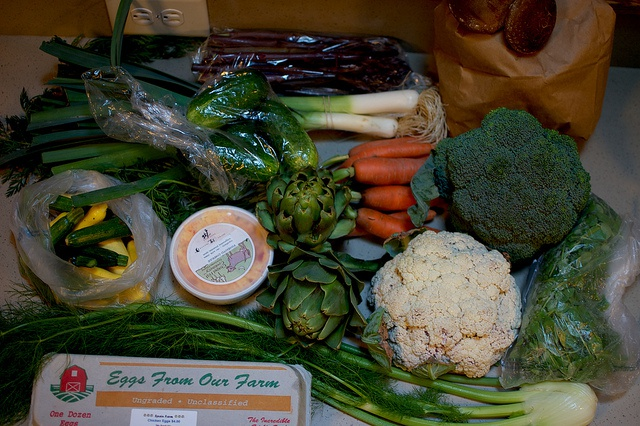Describe the objects in this image and their specific colors. I can see broccoli in maroon, black, darkgreen, teal, and gray tones, carrot in maroon, brown, and olive tones, carrot in maroon, brown, and black tones, carrot in maroon, brown, and black tones, and carrot in maroon and brown tones in this image. 